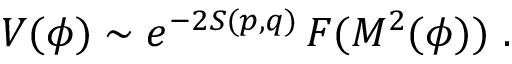Convert formula to latex. <formula><loc_0><loc_0><loc_500><loc_500>V ( \phi ) \sim { e ^ { - 2 S ( p , q ) } } \, F ( M ^ { 2 } ( \phi ) ) \ .</formula> 